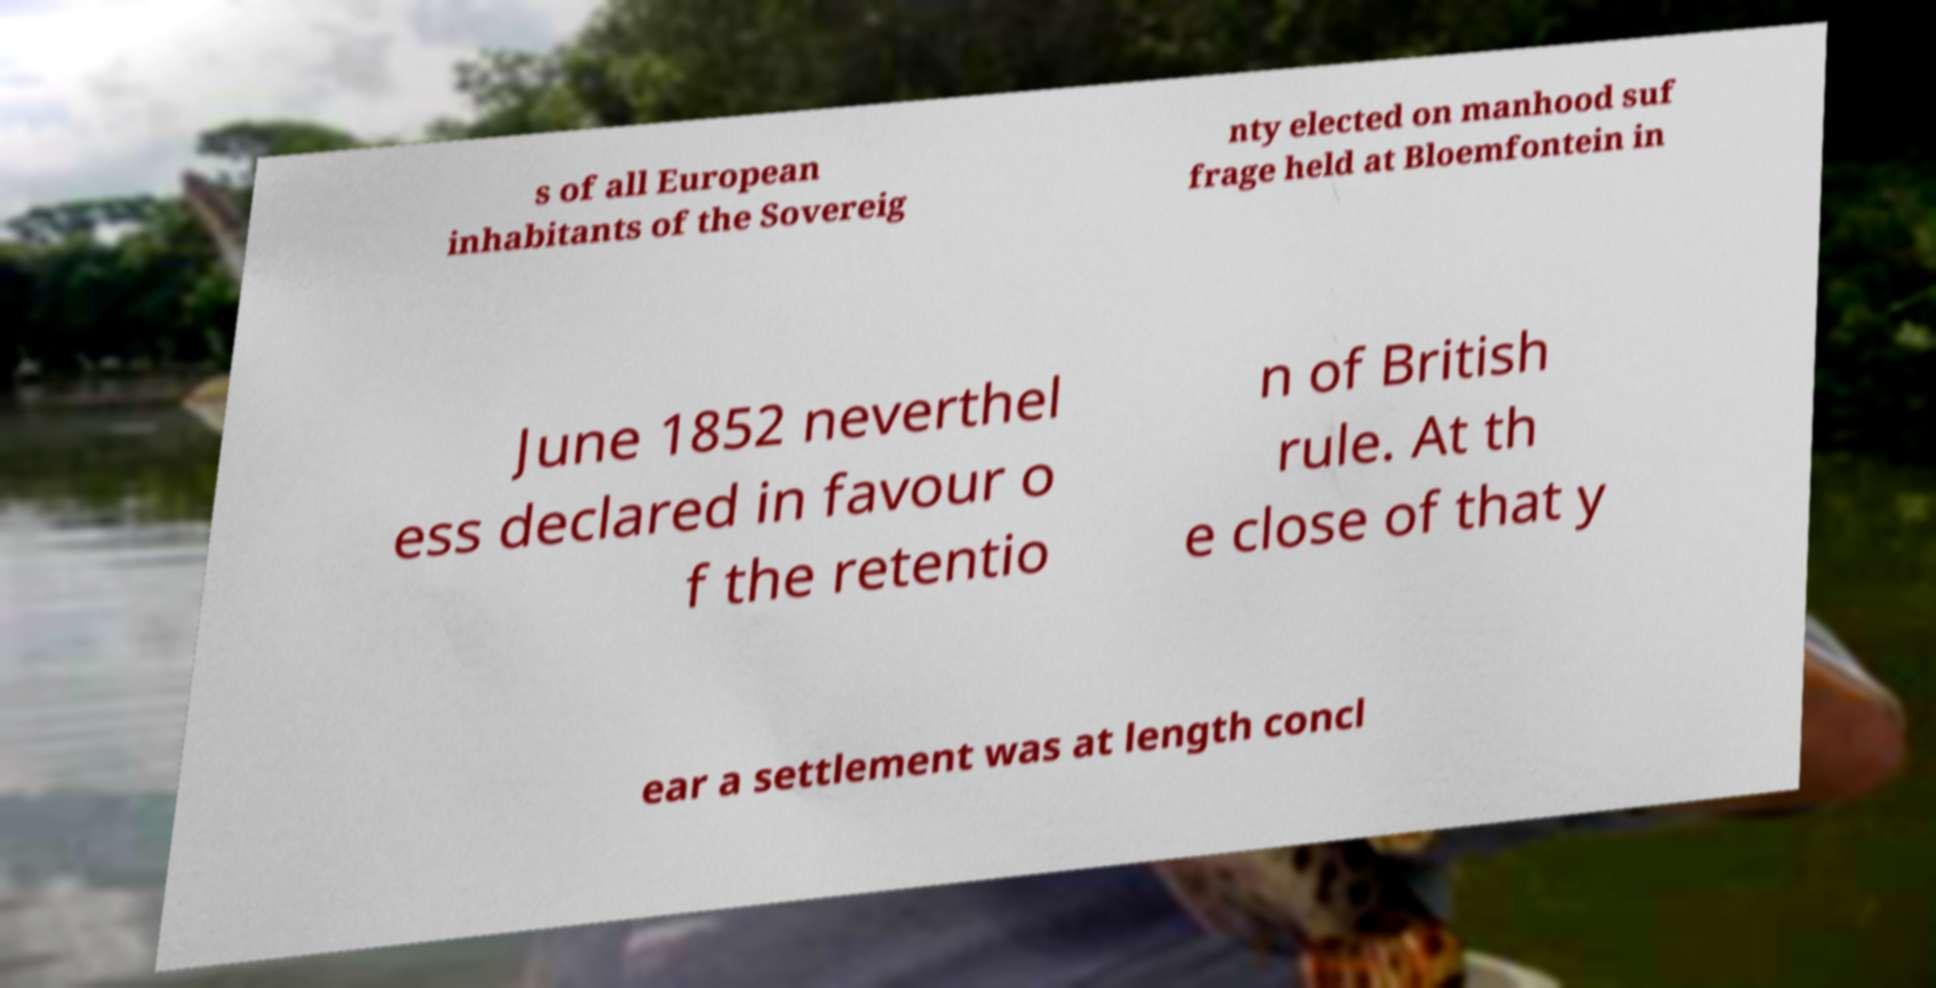Please identify and transcribe the text found in this image. s of all European inhabitants of the Sovereig nty elected on manhood suf frage held at Bloemfontein in June 1852 neverthel ess declared in favour o f the retentio n of British rule. At th e close of that y ear a settlement was at length concl 